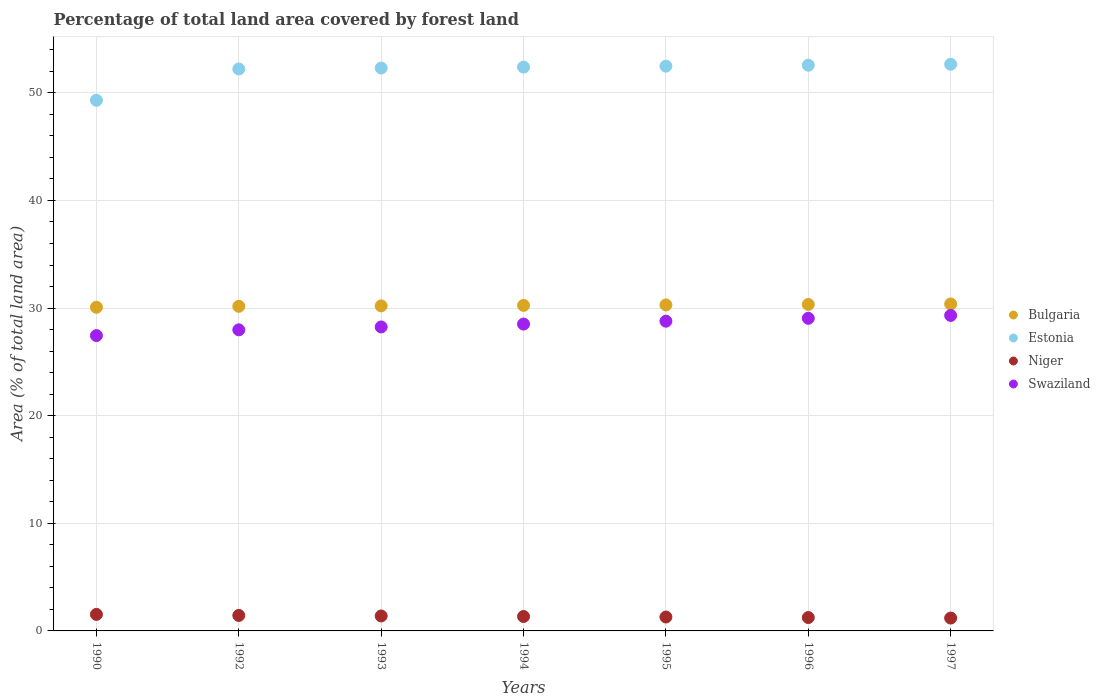What is the percentage of forest land in Niger in 1990?
Your answer should be very brief. 1.54. Across all years, what is the maximum percentage of forest land in Swaziland?
Make the answer very short. 29.31. Across all years, what is the minimum percentage of forest land in Estonia?
Your answer should be very brief. 49.3. In which year was the percentage of forest land in Niger maximum?
Ensure brevity in your answer.  1990. In which year was the percentage of forest land in Swaziland minimum?
Offer a terse response. 1990. What is the total percentage of forest land in Estonia in the graph?
Keep it short and to the point. 363.9. What is the difference between the percentage of forest land in Estonia in 1992 and that in 1996?
Your response must be concise. -0.35. What is the difference between the percentage of forest land in Estonia in 1990 and the percentage of forest land in Swaziland in 1996?
Give a very brief answer. 20.26. What is the average percentage of forest land in Estonia per year?
Offer a terse response. 51.99. In the year 1992, what is the difference between the percentage of forest land in Niger and percentage of forest land in Estonia?
Keep it short and to the point. -50.78. What is the ratio of the percentage of forest land in Niger in 1992 to that in 1993?
Ensure brevity in your answer.  1.04. Is the difference between the percentage of forest land in Niger in 1992 and 1997 greater than the difference between the percentage of forest land in Estonia in 1992 and 1997?
Make the answer very short. Yes. What is the difference between the highest and the second highest percentage of forest land in Estonia?
Give a very brief answer. 0.09. What is the difference between the highest and the lowest percentage of forest land in Estonia?
Make the answer very short. 3.35. In how many years, is the percentage of forest land in Estonia greater than the average percentage of forest land in Estonia taken over all years?
Provide a succinct answer. 6. Is it the case that in every year, the sum of the percentage of forest land in Estonia and percentage of forest land in Niger  is greater than the percentage of forest land in Bulgaria?
Your answer should be compact. Yes. Does the percentage of forest land in Estonia monotonically increase over the years?
Your answer should be compact. Yes. Is the percentage of forest land in Bulgaria strictly less than the percentage of forest land in Estonia over the years?
Ensure brevity in your answer.  Yes. What is the difference between two consecutive major ticks on the Y-axis?
Your response must be concise. 10. Where does the legend appear in the graph?
Provide a short and direct response. Center right. How many legend labels are there?
Your answer should be compact. 4. What is the title of the graph?
Keep it short and to the point. Percentage of total land area covered by forest land. Does "Antigua and Barbuda" appear as one of the legend labels in the graph?
Your answer should be compact. No. What is the label or title of the Y-axis?
Your response must be concise. Area (% of total land area). What is the Area (% of total land area) in Bulgaria in 1990?
Offer a very short reply. 30.07. What is the Area (% of total land area) in Estonia in 1990?
Ensure brevity in your answer.  49.3. What is the Area (% of total land area) of Niger in 1990?
Offer a terse response. 1.54. What is the Area (% of total land area) in Swaziland in 1990?
Ensure brevity in your answer.  27.44. What is the Area (% of total land area) of Bulgaria in 1992?
Your response must be concise. 30.16. What is the Area (% of total land area) in Estonia in 1992?
Provide a succinct answer. 52.22. What is the Area (% of total land area) in Niger in 1992?
Give a very brief answer. 1.44. What is the Area (% of total land area) of Swaziland in 1992?
Give a very brief answer. 27.98. What is the Area (% of total land area) of Bulgaria in 1993?
Provide a short and direct response. 30.2. What is the Area (% of total land area) of Estonia in 1993?
Ensure brevity in your answer.  52.3. What is the Area (% of total land area) in Niger in 1993?
Make the answer very short. 1.39. What is the Area (% of total land area) of Swaziland in 1993?
Your answer should be compact. 28.24. What is the Area (% of total land area) of Bulgaria in 1994?
Ensure brevity in your answer.  30.25. What is the Area (% of total land area) of Estonia in 1994?
Your answer should be very brief. 52.39. What is the Area (% of total land area) of Niger in 1994?
Give a very brief answer. 1.34. What is the Area (% of total land area) in Swaziland in 1994?
Offer a very short reply. 28.51. What is the Area (% of total land area) in Bulgaria in 1995?
Offer a very short reply. 30.29. What is the Area (% of total land area) in Estonia in 1995?
Your answer should be compact. 52.48. What is the Area (% of total land area) of Niger in 1995?
Your answer should be compact. 1.29. What is the Area (% of total land area) of Swaziland in 1995?
Offer a terse response. 28.78. What is the Area (% of total land area) in Bulgaria in 1996?
Your answer should be very brief. 30.33. What is the Area (% of total land area) of Estonia in 1996?
Your answer should be very brief. 52.56. What is the Area (% of total land area) in Niger in 1996?
Ensure brevity in your answer.  1.24. What is the Area (% of total land area) in Swaziland in 1996?
Offer a very short reply. 29.05. What is the Area (% of total land area) in Bulgaria in 1997?
Offer a very short reply. 30.38. What is the Area (% of total land area) in Estonia in 1997?
Offer a terse response. 52.65. What is the Area (% of total land area) of Niger in 1997?
Your response must be concise. 1.19. What is the Area (% of total land area) of Swaziland in 1997?
Provide a short and direct response. 29.31. Across all years, what is the maximum Area (% of total land area) in Bulgaria?
Provide a short and direct response. 30.38. Across all years, what is the maximum Area (% of total land area) of Estonia?
Your answer should be compact. 52.65. Across all years, what is the maximum Area (% of total land area) in Niger?
Your answer should be very brief. 1.54. Across all years, what is the maximum Area (% of total land area) in Swaziland?
Your answer should be compact. 29.31. Across all years, what is the minimum Area (% of total land area) in Bulgaria?
Keep it short and to the point. 30.07. Across all years, what is the minimum Area (% of total land area) in Estonia?
Your answer should be compact. 49.3. Across all years, what is the minimum Area (% of total land area) in Niger?
Your answer should be very brief. 1.19. Across all years, what is the minimum Area (% of total land area) in Swaziland?
Provide a succinct answer. 27.44. What is the total Area (% of total land area) in Bulgaria in the graph?
Offer a very short reply. 211.68. What is the total Area (% of total land area) in Estonia in the graph?
Your response must be concise. 363.9. What is the total Area (% of total land area) of Niger in the graph?
Keep it short and to the point. 9.43. What is the total Area (% of total land area) in Swaziland in the graph?
Give a very brief answer. 199.31. What is the difference between the Area (% of total land area) in Bulgaria in 1990 and that in 1992?
Keep it short and to the point. -0.09. What is the difference between the Area (% of total land area) in Estonia in 1990 and that in 1992?
Offer a very short reply. -2.91. What is the difference between the Area (% of total land area) of Niger in 1990 and that in 1992?
Provide a succinct answer. 0.1. What is the difference between the Area (% of total land area) in Swaziland in 1990 and that in 1992?
Provide a succinct answer. -0.53. What is the difference between the Area (% of total land area) of Bulgaria in 1990 and that in 1993?
Your answer should be compact. -0.13. What is the difference between the Area (% of total land area) of Estonia in 1990 and that in 1993?
Your answer should be compact. -3. What is the difference between the Area (% of total land area) of Niger in 1990 and that in 1993?
Provide a short and direct response. 0.15. What is the difference between the Area (% of total land area) of Swaziland in 1990 and that in 1993?
Give a very brief answer. -0.8. What is the difference between the Area (% of total land area) in Bulgaria in 1990 and that in 1994?
Ensure brevity in your answer.  -0.17. What is the difference between the Area (% of total land area) in Estonia in 1990 and that in 1994?
Keep it short and to the point. -3.09. What is the difference between the Area (% of total land area) of Niger in 1990 and that in 1994?
Make the answer very short. 0.19. What is the difference between the Area (% of total land area) in Swaziland in 1990 and that in 1994?
Ensure brevity in your answer.  -1.07. What is the difference between the Area (% of total land area) in Bulgaria in 1990 and that in 1995?
Provide a short and direct response. -0.22. What is the difference between the Area (% of total land area) of Estonia in 1990 and that in 1995?
Ensure brevity in your answer.  -3.17. What is the difference between the Area (% of total land area) in Niger in 1990 and that in 1995?
Offer a terse response. 0.24. What is the difference between the Area (% of total land area) in Swaziland in 1990 and that in 1995?
Your answer should be compact. -1.34. What is the difference between the Area (% of total land area) of Bulgaria in 1990 and that in 1996?
Give a very brief answer. -0.26. What is the difference between the Area (% of total land area) in Estonia in 1990 and that in 1996?
Keep it short and to the point. -3.26. What is the difference between the Area (% of total land area) in Niger in 1990 and that in 1996?
Your answer should be compact. 0.29. What is the difference between the Area (% of total land area) in Swaziland in 1990 and that in 1996?
Offer a very short reply. -1.6. What is the difference between the Area (% of total land area) in Bulgaria in 1990 and that in 1997?
Provide a short and direct response. -0.3. What is the difference between the Area (% of total land area) in Estonia in 1990 and that in 1997?
Your answer should be very brief. -3.35. What is the difference between the Area (% of total land area) in Niger in 1990 and that in 1997?
Offer a very short reply. 0.34. What is the difference between the Area (% of total land area) in Swaziland in 1990 and that in 1997?
Your answer should be compact. -1.87. What is the difference between the Area (% of total land area) in Bulgaria in 1992 and that in 1993?
Your answer should be very brief. -0.04. What is the difference between the Area (% of total land area) in Estonia in 1992 and that in 1993?
Keep it short and to the point. -0.09. What is the difference between the Area (% of total land area) in Niger in 1992 and that in 1993?
Make the answer very short. 0.05. What is the difference between the Area (% of total land area) in Swaziland in 1992 and that in 1993?
Offer a terse response. -0.27. What is the difference between the Area (% of total land area) of Bulgaria in 1992 and that in 1994?
Offer a very short reply. -0.09. What is the difference between the Area (% of total land area) of Estonia in 1992 and that in 1994?
Provide a succinct answer. -0.17. What is the difference between the Area (% of total land area) in Niger in 1992 and that in 1994?
Your answer should be compact. 0.1. What is the difference between the Area (% of total land area) in Swaziland in 1992 and that in 1994?
Make the answer very short. -0.53. What is the difference between the Area (% of total land area) of Bulgaria in 1992 and that in 1995?
Offer a very short reply. -0.13. What is the difference between the Area (% of total land area) in Estonia in 1992 and that in 1995?
Provide a short and direct response. -0.26. What is the difference between the Area (% of total land area) of Niger in 1992 and that in 1995?
Your response must be concise. 0.15. What is the difference between the Area (% of total land area) of Swaziland in 1992 and that in 1995?
Provide a succinct answer. -0.8. What is the difference between the Area (% of total land area) of Bulgaria in 1992 and that in 1996?
Your answer should be compact. -0.17. What is the difference between the Area (% of total land area) of Estonia in 1992 and that in 1996?
Give a very brief answer. -0.35. What is the difference between the Area (% of total land area) of Niger in 1992 and that in 1996?
Offer a terse response. 0.19. What is the difference between the Area (% of total land area) of Swaziland in 1992 and that in 1996?
Your answer should be compact. -1.07. What is the difference between the Area (% of total land area) in Bulgaria in 1992 and that in 1997?
Give a very brief answer. -0.22. What is the difference between the Area (% of total land area) in Estonia in 1992 and that in 1997?
Offer a terse response. -0.44. What is the difference between the Area (% of total land area) in Niger in 1992 and that in 1997?
Provide a short and direct response. 0.24. What is the difference between the Area (% of total land area) of Swaziland in 1992 and that in 1997?
Provide a short and direct response. -1.34. What is the difference between the Area (% of total land area) in Bulgaria in 1993 and that in 1994?
Provide a succinct answer. -0.04. What is the difference between the Area (% of total land area) of Estonia in 1993 and that in 1994?
Ensure brevity in your answer.  -0.09. What is the difference between the Area (% of total land area) in Niger in 1993 and that in 1994?
Give a very brief answer. 0.05. What is the difference between the Area (% of total land area) in Swaziland in 1993 and that in 1994?
Ensure brevity in your answer.  -0.27. What is the difference between the Area (% of total land area) of Bulgaria in 1993 and that in 1995?
Offer a terse response. -0.09. What is the difference between the Area (% of total land area) in Estonia in 1993 and that in 1995?
Give a very brief answer. -0.17. What is the difference between the Area (% of total land area) of Niger in 1993 and that in 1995?
Make the answer very short. 0.1. What is the difference between the Area (% of total land area) of Swaziland in 1993 and that in 1995?
Your answer should be very brief. -0.53. What is the difference between the Area (% of total land area) in Bulgaria in 1993 and that in 1996?
Offer a very short reply. -0.13. What is the difference between the Area (% of total land area) of Estonia in 1993 and that in 1996?
Keep it short and to the point. -0.26. What is the difference between the Area (% of total land area) of Niger in 1993 and that in 1996?
Make the answer very short. 0.15. What is the difference between the Area (% of total land area) of Swaziland in 1993 and that in 1996?
Make the answer very short. -0.8. What is the difference between the Area (% of total land area) in Bulgaria in 1993 and that in 1997?
Your answer should be very brief. -0.17. What is the difference between the Area (% of total land area) in Estonia in 1993 and that in 1997?
Provide a succinct answer. -0.35. What is the difference between the Area (% of total land area) in Niger in 1993 and that in 1997?
Your answer should be very brief. 0.19. What is the difference between the Area (% of total land area) in Swaziland in 1993 and that in 1997?
Keep it short and to the point. -1.07. What is the difference between the Area (% of total land area) in Bulgaria in 1994 and that in 1995?
Your answer should be compact. -0.04. What is the difference between the Area (% of total land area) in Estonia in 1994 and that in 1995?
Keep it short and to the point. -0.09. What is the difference between the Area (% of total land area) in Niger in 1994 and that in 1995?
Your answer should be compact. 0.05. What is the difference between the Area (% of total land area) in Swaziland in 1994 and that in 1995?
Make the answer very short. -0.27. What is the difference between the Area (% of total land area) in Bulgaria in 1994 and that in 1996?
Offer a terse response. -0.09. What is the difference between the Area (% of total land area) in Estonia in 1994 and that in 1996?
Offer a terse response. -0.17. What is the difference between the Area (% of total land area) of Niger in 1994 and that in 1996?
Your response must be concise. 0.1. What is the difference between the Area (% of total land area) of Swaziland in 1994 and that in 1996?
Your response must be concise. -0.53. What is the difference between the Area (% of total land area) of Bulgaria in 1994 and that in 1997?
Your answer should be very brief. -0.13. What is the difference between the Area (% of total land area) of Estonia in 1994 and that in 1997?
Your answer should be very brief. -0.26. What is the difference between the Area (% of total land area) of Niger in 1994 and that in 1997?
Make the answer very short. 0.15. What is the difference between the Area (% of total land area) of Swaziland in 1994 and that in 1997?
Provide a short and direct response. -0.8. What is the difference between the Area (% of total land area) of Bulgaria in 1995 and that in 1996?
Your response must be concise. -0.04. What is the difference between the Area (% of total land area) in Estonia in 1995 and that in 1996?
Offer a very short reply. -0.09. What is the difference between the Area (% of total land area) of Niger in 1995 and that in 1996?
Your answer should be very brief. 0.05. What is the difference between the Area (% of total land area) in Swaziland in 1995 and that in 1996?
Provide a succinct answer. -0.27. What is the difference between the Area (% of total land area) of Bulgaria in 1995 and that in 1997?
Keep it short and to the point. -0.09. What is the difference between the Area (% of total land area) in Estonia in 1995 and that in 1997?
Keep it short and to the point. -0.17. What is the difference between the Area (% of total land area) in Niger in 1995 and that in 1997?
Give a very brief answer. 0.1. What is the difference between the Area (% of total land area) of Swaziland in 1995 and that in 1997?
Your answer should be compact. -0.53. What is the difference between the Area (% of total land area) of Bulgaria in 1996 and that in 1997?
Keep it short and to the point. -0.04. What is the difference between the Area (% of total land area) in Estonia in 1996 and that in 1997?
Provide a succinct answer. -0.09. What is the difference between the Area (% of total land area) in Niger in 1996 and that in 1997?
Your answer should be very brief. 0.05. What is the difference between the Area (% of total land area) of Swaziland in 1996 and that in 1997?
Your response must be concise. -0.27. What is the difference between the Area (% of total land area) in Bulgaria in 1990 and the Area (% of total land area) in Estonia in 1992?
Your answer should be compact. -22.14. What is the difference between the Area (% of total land area) of Bulgaria in 1990 and the Area (% of total land area) of Niger in 1992?
Make the answer very short. 28.64. What is the difference between the Area (% of total land area) of Bulgaria in 1990 and the Area (% of total land area) of Swaziland in 1992?
Provide a short and direct response. 2.1. What is the difference between the Area (% of total land area) in Estonia in 1990 and the Area (% of total land area) in Niger in 1992?
Provide a short and direct response. 47.87. What is the difference between the Area (% of total land area) in Estonia in 1990 and the Area (% of total land area) in Swaziland in 1992?
Make the answer very short. 21.33. What is the difference between the Area (% of total land area) of Niger in 1990 and the Area (% of total land area) of Swaziland in 1992?
Give a very brief answer. -26.44. What is the difference between the Area (% of total land area) of Bulgaria in 1990 and the Area (% of total land area) of Estonia in 1993?
Your response must be concise. -22.23. What is the difference between the Area (% of total land area) of Bulgaria in 1990 and the Area (% of total land area) of Niger in 1993?
Your answer should be compact. 28.68. What is the difference between the Area (% of total land area) of Bulgaria in 1990 and the Area (% of total land area) of Swaziland in 1993?
Provide a short and direct response. 1.83. What is the difference between the Area (% of total land area) of Estonia in 1990 and the Area (% of total land area) of Niger in 1993?
Ensure brevity in your answer.  47.91. What is the difference between the Area (% of total land area) in Estonia in 1990 and the Area (% of total land area) in Swaziland in 1993?
Offer a terse response. 21.06. What is the difference between the Area (% of total land area) in Niger in 1990 and the Area (% of total land area) in Swaziland in 1993?
Your response must be concise. -26.71. What is the difference between the Area (% of total land area) in Bulgaria in 1990 and the Area (% of total land area) in Estonia in 1994?
Offer a very short reply. -22.32. What is the difference between the Area (% of total land area) of Bulgaria in 1990 and the Area (% of total land area) of Niger in 1994?
Provide a short and direct response. 28.73. What is the difference between the Area (% of total land area) of Bulgaria in 1990 and the Area (% of total land area) of Swaziland in 1994?
Offer a terse response. 1.56. What is the difference between the Area (% of total land area) of Estonia in 1990 and the Area (% of total land area) of Niger in 1994?
Give a very brief answer. 47.96. What is the difference between the Area (% of total land area) in Estonia in 1990 and the Area (% of total land area) in Swaziland in 1994?
Offer a terse response. 20.79. What is the difference between the Area (% of total land area) in Niger in 1990 and the Area (% of total land area) in Swaziland in 1994?
Offer a terse response. -26.98. What is the difference between the Area (% of total land area) in Bulgaria in 1990 and the Area (% of total land area) in Estonia in 1995?
Give a very brief answer. -22.4. What is the difference between the Area (% of total land area) of Bulgaria in 1990 and the Area (% of total land area) of Niger in 1995?
Give a very brief answer. 28.78. What is the difference between the Area (% of total land area) in Bulgaria in 1990 and the Area (% of total land area) in Swaziland in 1995?
Provide a short and direct response. 1.29. What is the difference between the Area (% of total land area) in Estonia in 1990 and the Area (% of total land area) in Niger in 1995?
Your answer should be very brief. 48.01. What is the difference between the Area (% of total land area) of Estonia in 1990 and the Area (% of total land area) of Swaziland in 1995?
Your answer should be very brief. 20.52. What is the difference between the Area (% of total land area) in Niger in 1990 and the Area (% of total land area) in Swaziland in 1995?
Provide a succinct answer. -27.24. What is the difference between the Area (% of total land area) of Bulgaria in 1990 and the Area (% of total land area) of Estonia in 1996?
Make the answer very short. -22.49. What is the difference between the Area (% of total land area) of Bulgaria in 1990 and the Area (% of total land area) of Niger in 1996?
Provide a short and direct response. 28.83. What is the difference between the Area (% of total land area) of Bulgaria in 1990 and the Area (% of total land area) of Swaziland in 1996?
Make the answer very short. 1.03. What is the difference between the Area (% of total land area) of Estonia in 1990 and the Area (% of total land area) of Niger in 1996?
Provide a succinct answer. 48.06. What is the difference between the Area (% of total land area) in Estonia in 1990 and the Area (% of total land area) in Swaziland in 1996?
Your answer should be compact. 20.26. What is the difference between the Area (% of total land area) in Niger in 1990 and the Area (% of total land area) in Swaziland in 1996?
Make the answer very short. -27.51. What is the difference between the Area (% of total land area) in Bulgaria in 1990 and the Area (% of total land area) in Estonia in 1997?
Provide a succinct answer. -22.58. What is the difference between the Area (% of total land area) in Bulgaria in 1990 and the Area (% of total land area) in Niger in 1997?
Your answer should be compact. 28.88. What is the difference between the Area (% of total land area) in Bulgaria in 1990 and the Area (% of total land area) in Swaziland in 1997?
Give a very brief answer. 0.76. What is the difference between the Area (% of total land area) of Estonia in 1990 and the Area (% of total land area) of Niger in 1997?
Your answer should be very brief. 48.11. What is the difference between the Area (% of total land area) of Estonia in 1990 and the Area (% of total land area) of Swaziland in 1997?
Keep it short and to the point. 19.99. What is the difference between the Area (% of total land area) of Niger in 1990 and the Area (% of total land area) of Swaziland in 1997?
Make the answer very short. -27.78. What is the difference between the Area (% of total land area) of Bulgaria in 1992 and the Area (% of total land area) of Estonia in 1993?
Give a very brief answer. -22.14. What is the difference between the Area (% of total land area) of Bulgaria in 1992 and the Area (% of total land area) of Niger in 1993?
Give a very brief answer. 28.77. What is the difference between the Area (% of total land area) of Bulgaria in 1992 and the Area (% of total land area) of Swaziland in 1993?
Your response must be concise. 1.92. What is the difference between the Area (% of total land area) in Estonia in 1992 and the Area (% of total land area) in Niger in 1993?
Make the answer very short. 50.83. What is the difference between the Area (% of total land area) of Estonia in 1992 and the Area (% of total land area) of Swaziland in 1993?
Give a very brief answer. 23.97. What is the difference between the Area (% of total land area) in Niger in 1992 and the Area (% of total land area) in Swaziland in 1993?
Provide a short and direct response. -26.81. What is the difference between the Area (% of total land area) of Bulgaria in 1992 and the Area (% of total land area) of Estonia in 1994?
Give a very brief answer. -22.23. What is the difference between the Area (% of total land area) in Bulgaria in 1992 and the Area (% of total land area) in Niger in 1994?
Provide a short and direct response. 28.82. What is the difference between the Area (% of total land area) in Bulgaria in 1992 and the Area (% of total land area) in Swaziland in 1994?
Your answer should be very brief. 1.65. What is the difference between the Area (% of total land area) of Estonia in 1992 and the Area (% of total land area) of Niger in 1994?
Provide a succinct answer. 50.87. What is the difference between the Area (% of total land area) of Estonia in 1992 and the Area (% of total land area) of Swaziland in 1994?
Provide a short and direct response. 23.7. What is the difference between the Area (% of total land area) in Niger in 1992 and the Area (% of total land area) in Swaziland in 1994?
Ensure brevity in your answer.  -27.07. What is the difference between the Area (% of total land area) in Bulgaria in 1992 and the Area (% of total land area) in Estonia in 1995?
Keep it short and to the point. -22.32. What is the difference between the Area (% of total land area) of Bulgaria in 1992 and the Area (% of total land area) of Niger in 1995?
Your answer should be compact. 28.87. What is the difference between the Area (% of total land area) in Bulgaria in 1992 and the Area (% of total land area) in Swaziland in 1995?
Your answer should be compact. 1.38. What is the difference between the Area (% of total land area) in Estonia in 1992 and the Area (% of total land area) in Niger in 1995?
Your response must be concise. 50.92. What is the difference between the Area (% of total land area) of Estonia in 1992 and the Area (% of total land area) of Swaziland in 1995?
Offer a terse response. 23.44. What is the difference between the Area (% of total land area) in Niger in 1992 and the Area (% of total land area) in Swaziland in 1995?
Ensure brevity in your answer.  -27.34. What is the difference between the Area (% of total land area) of Bulgaria in 1992 and the Area (% of total land area) of Estonia in 1996?
Your response must be concise. -22.4. What is the difference between the Area (% of total land area) in Bulgaria in 1992 and the Area (% of total land area) in Niger in 1996?
Provide a short and direct response. 28.92. What is the difference between the Area (% of total land area) of Bulgaria in 1992 and the Area (% of total land area) of Swaziland in 1996?
Make the answer very short. 1.11. What is the difference between the Area (% of total land area) in Estonia in 1992 and the Area (% of total land area) in Niger in 1996?
Your answer should be very brief. 50.97. What is the difference between the Area (% of total land area) of Estonia in 1992 and the Area (% of total land area) of Swaziland in 1996?
Your answer should be very brief. 23.17. What is the difference between the Area (% of total land area) in Niger in 1992 and the Area (% of total land area) in Swaziland in 1996?
Offer a very short reply. -27.61. What is the difference between the Area (% of total land area) in Bulgaria in 1992 and the Area (% of total land area) in Estonia in 1997?
Offer a terse response. -22.49. What is the difference between the Area (% of total land area) in Bulgaria in 1992 and the Area (% of total land area) in Niger in 1997?
Offer a very short reply. 28.97. What is the difference between the Area (% of total land area) in Bulgaria in 1992 and the Area (% of total land area) in Swaziland in 1997?
Ensure brevity in your answer.  0.85. What is the difference between the Area (% of total land area) in Estonia in 1992 and the Area (% of total land area) in Niger in 1997?
Provide a short and direct response. 51.02. What is the difference between the Area (% of total land area) of Estonia in 1992 and the Area (% of total land area) of Swaziland in 1997?
Give a very brief answer. 22.9. What is the difference between the Area (% of total land area) of Niger in 1992 and the Area (% of total land area) of Swaziland in 1997?
Your answer should be very brief. -27.88. What is the difference between the Area (% of total land area) in Bulgaria in 1993 and the Area (% of total land area) in Estonia in 1994?
Offer a very short reply. -22.19. What is the difference between the Area (% of total land area) of Bulgaria in 1993 and the Area (% of total land area) of Niger in 1994?
Keep it short and to the point. 28.86. What is the difference between the Area (% of total land area) in Bulgaria in 1993 and the Area (% of total land area) in Swaziland in 1994?
Give a very brief answer. 1.69. What is the difference between the Area (% of total land area) of Estonia in 1993 and the Area (% of total land area) of Niger in 1994?
Offer a terse response. 50.96. What is the difference between the Area (% of total land area) of Estonia in 1993 and the Area (% of total land area) of Swaziland in 1994?
Make the answer very short. 23.79. What is the difference between the Area (% of total land area) in Niger in 1993 and the Area (% of total land area) in Swaziland in 1994?
Keep it short and to the point. -27.12. What is the difference between the Area (% of total land area) in Bulgaria in 1993 and the Area (% of total land area) in Estonia in 1995?
Your response must be concise. -22.27. What is the difference between the Area (% of total land area) of Bulgaria in 1993 and the Area (% of total land area) of Niger in 1995?
Offer a very short reply. 28.91. What is the difference between the Area (% of total land area) in Bulgaria in 1993 and the Area (% of total land area) in Swaziland in 1995?
Keep it short and to the point. 1.42. What is the difference between the Area (% of total land area) in Estonia in 1993 and the Area (% of total land area) in Niger in 1995?
Your answer should be very brief. 51.01. What is the difference between the Area (% of total land area) in Estonia in 1993 and the Area (% of total land area) in Swaziland in 1995?
Offer a terse response. 23.52. What is the difference between the Area (% of total land area) of Niger in 1993 and the Area (% of total land area) of Swaziland in 1995?
Your answer should be very brief. -27.39. What is the difference between the Area (% of total land area) of Bulgaria in 1993 and the Area (% of total land area) of Estonia in 1996?
Make the answer very short. -22.36. What is the difference between the Area (% of total land area) in Bulgaria in 1993 and the Area (% of total land area) in Niger in 1996?
Make the answer very short. 28.96. What is the difference between the Area (% of total land area) in Bulgaria in 1993 and the Area (% of total land area) in Swaziland in 1996?
Offer a very short reply. 1.16. What is the difference between the Area (% of total land area) of Estonia in 1993 and the Area (% of total land area) of Niger in 1996?
Offer a very short reply. 51.06. What is the difference between the Area (% of total land area) of Estonia in 1993 and the Area (% of total land area) of Swaziland in 1996?
Your answer should be compact. 23.26. What is the difference between the Area (% of total land area) of Niger in 1993 and the Area (% of total land area) of Swaziland in 1996?
Offer a terse response. -27.66. What is the difference between the Area (% of total land area) of Bulgaria in 1993 and the Area (% of total land area) of Estonia in 1997?
Give a very brief answer. -22.45. What is the difference between the Area (% of total land area) in Bulgaria in 1993 and the Area (% of total land area) in Niger in 1997?
Keep it short and to the point. 29.01. What is the difference between the Area (% of total land area) of Bulgaria in 1993 and the Area (% of total land area) of Swaziland in 1997?
Make the answer very short. 0.89. What is the difference between the Area (% of total land area) in Estonia in 1993 and the Area (% of total land area) in Niger in 1997?
Your answer should be compact. 51.11. What is the difference between the Area (% of total land area) of Estonia in 1993 and the Area (% of total land area) of Swaziland in 1997?
Ensure brevity in your answer.  22.99. What is the difference between the Area (% of total land area) in Niger in 1993 and the Area (% of total land area) in Swaziland in 1997?
Your answer should be very brief. -27.92. What is the difference between the Area (% of total land area) in Bulgaria in 1994 and the Area (% of total land area) in Estonia in 1995?
Offer a very short reply. -22.23. What is the difference between the Area (% of total land area) of Bulgaria in 1994 and the Area (% of total land area) of Niger in 1995?
Provide a succinct answer. 28.95. What is the difference between the Area (% of total land area) of Bulgaria in 1994 and the Area (% of total land area) of Swaziland in 1995?
Your response must be concise. 1.47. What is the difference between the Area (% of total land area) of Estonia in 1994 and the Area (% of total land area) of Niger in 1995?
Give a very brief answer. 51.1. What is the difference between the Area (% of total land area) of Estonia in 1994 and the Area (% of total land area) of Swaziland in 1995?
Provide a succinct answer. 23.61. What is the difference between the Area (% of total land area) of Niger in 1994 and the Area (% of total land area) of Swaziland in 1995?
Provide a short and direct response. -27.44. What is the difference between the Area (% of total land area) in Bulgaria in 1994 and the Area (% of total land area) in Estonia in 1996?
Offer a very short reply. -22.32. What is the difference between the Area (% of total land area) in Bulgaria in 1994 and the Area (% of total land area) in Niger in 1996?
Offer a very short reply. 29. What is the difference between the Area (% of total land area) in Bulgaria in 1994 and the Area (% of total land area) in Swaziland in 1996?
Offer a very short reply. 1.2. What is the difference between the Area (% of total land area) in Estonia in 1994 and the Area (% of total land area) in Niger in 1996?
Make the answer very short. 51.15. What is the difference between the Area (% of total land area) in Estonia in 1994 and the Area (% of total land area) in Swaziland in 1996?
Keep it short and to the point. 23.34. What is the difference between the Area (% of total land area) in Niger in 1994 and the Area (% of total land area) in Swaziland in 1996?
Make the answer very short. -27.71. What is the difference between the Area (% of total land area) of Bulgaria in 1994 and the Area (% of total land area) of Estonia in 1997?
Offer a very short reply. -22.4. What is the difference between the Area (% of total land area) in Bulgaria in 1994 and the Area (% of total land area) in Niger in 1997?
Your answer should be very brief. 29.05. What is the difference between the Area (% of total land area) of Bulgaria in 1994 and the Area (% of total land area) of Swaziland in 1997?
Keep it short and to the point. 0.93. What is the difference between the Area (% of total land area) of Estonia in 1994 and the Area (% of total land area) of Niger in 1997?
Offer a terse response. 51.2. What is the difference between the Area (% of total land area) in Estonia in 1994 and the Area (% of total land area) in Swaziland in 1997?
Provide a succinct answer. 23.08. What is the difference between the Area (% of total land area) of Niger in 1994 and the Area (% of total land area) of Swaziland in 1997?
Make the answer very short. -27.97. What is the difference between the Area (% of total land area) in Bulgaria in 1995 and the Area (% of total land area) in Estonia in 1996?
Your answer should be compact. -22.27. What is the difference between the Area (% of total land area) of Bulgaria in 1995 and the Area (% of total land area) of Niger in 1996?
Ensure brevity in your answer.  29.05. What is the difference between the Area (% of total land area) in Bulgaria in 1995 and the Area (% of total land area) in Swaziland in 1996?
Ensure brevity in your answer.  1.24. What is the difference between the Area (% of total land area) of Estonia in 1995 and the Area (% of total land area) of Niger in 1996?
Provide a short and direct response. 51.23. What is the difference between the Area (% of total land area) of Estonia in 1995 and the Area (% of total land area) of Swaziland in 1996?
Give a very brief answer. 23.43. What is the difference between the Area (% of total land area) in Niger in 1995 and the Area (% of total land area) in Swaziland in 1996?
Offer a terse response. -27.75. What is the difference between the Area (% of total land area) of Bulgaria in 1995 and the Area (% of total land area) of Estonia in 1997?
Offer a terse response. -22.36. What is the difference between the Area (% of total land area) in Bulgaria in 1995 and the Area (% of total land area) in Niger in 1997?
Your answer should be compact. 29.1. What is the difference between the Area (% of total land area) of Bulgaria in 1995 and the Area (% of total land area) of Swaziland in 1997?
Ensure brevity in your answer.  0.98. What is the difference between the Area (% of total land area) of Estonia in 1995 and the Area (% of total land area) of Niger in 1997?
Offer a very short reply. 51.28. What is the difference between the Area (% of total land area) of Estonia in 1995 and the Area (% of total land area) of Swaziland in 1997?
Your answer should be compact. 23.16. What is the difference between the Area (% of total land area) in Niger in 1995 and the Area (% of total land area) in Swaziland in 1997?
Provide a succinct answer. -28.02. What is the difference between the Area (% of total land area) of Bulgaria in 1996 and the Area (% of total land area) of Estonia in 1997?
Offer a terse response. -22.32. What is the difference between the Area (% of total land area) of Bulgaria in 1996 and the Area (% of total land area) of Niger in 1997?
Provide a short and direct response. 29.14. What is the difference between the Area (% of total land area) of Bulgaria in 1996 and the Area (% of total land area) of Swaziland in 1997?
Make the answer very short. 1.02. What is the difference between the Area (% of total land area) in Estonia in 1996 and the Area (% of total land area) in Niger in 1997?
Make the answer very short. 51.37. What is the difference between the Area (% of total land area) of Estonia in 1996 and the Area (% of total land area) of Swaziland in 1997?
Give a very brief answer. 23.25. What is the difference between the Area (% of total land area) of Niger in 1996 and the Area (% of total land area) of Swaziland in 1997?
Provide a short and direct response. -28.07. What is the average Area (% of total land area) of Bulgaria per year?
Make the answer very short. 30.24. What is the average Area (% of total land area) of Estonia per year?
Keep it short and to the point. 51.99. What is the average Area (% of total land area) of Niger per year?
Ensure brevity in your answer.  1.35. What is the average Area (% of total land area) in Swaziland per year?
Offer a terse response. 28.47. In the year 1990, what is the difference between the Area (% of total land area) in Bulgaria and Area (% of total land area) in Estonia?
Your response must be concise. -19.23. In the year 1990, what is the difference between the Area (% of total land area) of Bulgaria and Area (% of total land area) of Niger?
Give a very brief answer. 28.54. In the year 1990, what is the difference between the Area (% of total land area) in Bulgaria and Area (% of total land area) in Swaziland?
Your answer should be very brief. 2.63. In the year 1990, what is the difference between the Area (% of total land area) in Estonia and Area (% of total land area) in Niger?
Make the answer very short. 47.77. In the year 1990, what is the difference between the Area (% of total land area) in Estonia and Area (% of total land area) in Swaziland?
Ensure brevity in your answer.  21.86. In the year 1990, what is the difference between the Area (% of total land area) in Niger and Area (% of total land area) in Swaziland?
Your answer should be very brief. -25.91. In the year 1992, what is the difference between the Area (% of total land area) in Bulgaria and Area (% of total land area) in Estonia?
Your answer should be very brief. -22.06. In the year 1992, what is the difference between the Area (% of total land area) of Bulgaria and Area (% of total land area) of Niger?
Provide a short and direct response. 28.72. In the year 1992, what is the difference between the Area (% of total land area) in Bulgaria and Area (% of total land area) in Swaziland?
Offer a terse response. 2.18. In the year 1992, what is the difference between the Area (% of total land area) in Estonia and Area (% of total land area) in Niger?
Offer a terse response. 50.78. In the year 1992, what is the difference between the Area (% of total land area) of Estonia and Area (% of total land area) of Swaziland?
Give a very brief answer. 24.24. In the year 1992, what is the difference between the Area (% of total land area) of Niger and Area (% of total land area) of Swaziland?
Keep it short and to the point. -26.54. In the year 1993, what is the difference between the Area (% of total land area) in Bulgaria and Area (% of total land area) in Estonia?
Make the answer very short. -22.1. In the year 1993, what is the difference between the Area (% of total land area) in Bulgaria and Area (% of total land area) in Niger?
Your response must be concise. 28.81. In the year 1993, what is the difference between the Area (% of total land area) of Bulgaria and Area (% of total land area) of Swaziland?
Ensure brevity in your answer.  1.96. In the year 1993, what is the difference between the Area (% of total land area) of Estonia and Area (% of total land area) of Niger?
Your answer should be very brief. 50.91. In the year 1993, what is the difference between the Area (% of total land area) in Estonia and Area (% of total land area) in Swaziland?
Offer a terse response. 24.06. In the year 1993, what is the difference between the Area (% of total land area) of Niger and Area (% of total land area) of Swaziland?
Make the answer very short. -26.85. In the year 1994, what is the difference between the Area (% of total land area) in Bulgaria and Area (% of total land area) in Estonia?
Offer a terse response. -22.14. In the year 1994, what is the difference between the Area (% of total land area) of Bulgaria and Area (% of total land area) of Niger?
Make the answer very short. 28.91. In the year 1994, what is the difference between the Area (% of total land area) in Bulgaria and Area (% of total land area) in Swaziland?
Keep it short and to the point. 1.74. In the year 1994, what is the difference between the Area (% of total land area) in Estonia and Area (% of total land area) in Niger?
Provide a succinct answer. 51.05. In the year 1994, what is the difference between the Area (% of total land area) of Estonia and Area (% of total land area) of Swaziland?
Your response must be concise. 23.88. In the year 1994, what is the difference between the Area (% of total land area) of Niger and Area (% of total land area) of Swaziland?
Your answer should be very brief. -27.17. In the year 1995, what is the difference between the Area (% of total land area) of Bulgaria and Area (% of total land area) of Estonia?
Ensure brevity in your answer.  -22.19. In the year 1995, what is the difference between the Area (% of total land area) in Bulgaria and Area (% of total land area) in Niger?
Your answer should be very brief. 29. In the year 1995, what is the difference between the Area (% of total land area) in Bulgaria and Area (% of total land area) in Swaziland?
Your answer should be very brief. 1.51. In the year 1995, what is the difference between the Area (% of total land area) of Estonia and Area (% of total land area) of Niger?
Give a very brief answer. 51.19. In the year 1995, what is the difference between the Area (% of total land area) of Estonia and Area (% of total land area) of Swaziland?
Offer a terse response. 23.7. In the year 1995, what is the difference between the Area (% of total land area) of Niger and Area (% of total land area) of Swaziland?
Give a very brief answer. -27.49. In the year 1996, what is the difference between the Area (% of total land area) of Bulgaria and Area (% of total land area) of Estonia?
Offer a terse response. -22.23. In the year 1996, what is the difference between the Area (% of total land area) of Bulgaria and Area (% of total land area) of Niger?
Offer a terse response. 29.09. In the year 1996, what is the difference between the Area (% of total land area) in Bulgaria and Area (% of total land area) in Swaziland?
Provide a succinct answer. 1.29. In the year 1996, what is the difference between the Area (% of total land area) in Estonia and Area (% of total land area) in Niger?
Your answer should be very brief. 51.32. In the year 1996, what is the difference between the Area (% of total land area) of Estonia and Area (% of total land area) of Swaziland?
Offer a terse response. 23.52. In the year 1996, what is the difference between the Area (% of total land area) of Niger and Area (% of total land area) of Swaziland?
Provide a succinct answer. -27.8. In the year 1997, what is the difference between the Area (% of total land area) of Bulgaria and Area (% of total land area) of Estonia?
Ensure brevity in your answer.  -22.27. In the year 1997, what is the difference between the Area (% of total land area) of Bulgaria and Area (% of total land area) of Niger?
Offer a very short reply. 29.18. In the year 1997, what is the difference between the Area (% of total land area) in Bulgaria and Area (% of total land area) in Swaziland?
Your response must be concise. 1.06. In the year 1997, what is the difference between the Area (% of total land area) of Estonia and Area (% of total land area) of Niger?
Your response must be concise. 51.46. In the year 1997, what is the difference between the Area (% of total land area) in Estonia and Area (% of total land area) in Swaziland?
Offer a very short reply. 23.34. In the year 1997, what is the difference between the Area (% of total land area) of Niger and Area (% of total land area) of Swaziland?
Offer a terse response. -28.12. What is the ratio of the Area (% of total land area) of Estonia in 1990 to that in 1992?
Your answer should be very brief. 0.94. What is the ratio of the Area (% of total land area) in Niger in 1990 to that in 1992?
Your answer should be compact. 1.07. What is the ratio of the Area (% of total land area) of Swaziland in 1990 to that in 1992?
Ensure brevity in your answer.  0.98. What is the ratio of the Area (% of total land area) of Bulgaria in 1990 to that in 1993?
Offer a very short reply. 1. What is the ratio of the Area (% of total land area) in Estonia in 1990 to that in 1993?
Offer a very short reply. 0.94. What is the ratio of the Area (% of total land area) in Niger in 1990 to that in 1993?
Your answer should be compact. 1.11. What is the ratio of the Area (% of total land area) in Swaziland in 1990 to that in 1993?
Make the answer very short. 0.97. What is the ratio of the Area (% of total land area) of Bulgaria in 1990 to that in 1994?
Make the answer very short. 0.99. What is the ratio of the Area (% of total land area) in Estonia in 1990 to that in 1994?
Make the answer very short. 0.94. What is the ratio of the Area (% of total land area) in Niger in 1990 to that in 1994?
Ensure brevity in your answer.  1.15. What is the ratio of the Area (% of total land area) in Swaziland in 1990 to that in 1994?
Provide a short and direct response. 0.96. What is the ratio of the Area (% of total land area) of Bulgaria in 1990 to that in 1995?
Keep it short and to the point. 0.99. What is the ratio of the Area (% of total land area) of Estonia in 1990 to that in 1995?
Make the answer very short. 0.94. What is the ratio of the Area (% of total land area) in Niger in 1990 to that in 1995?
Offer a terse response. 1.19. What is the ratio of the Area (% of total land area) of Swaziland in 1990 to that in 1995?
Your answer should be very brief. 0.95. What is the ratio of the Area (% of total land area) in Estonia in 1990 to that in 1996?
Make the answer very short. 0.94. What is the ratio of the Area (% of total land area) of Niger in 1990 to that in 1996?
Your answer should be compact. 1.24. What is the ratio of the Area (% of total land area) in Swaziland in 1990 to that in 1996?
Ensure brevity in your answer.  0.94. What is the ratio of the Area (% of total land area) in Estonia in 1990 to that in 1997?
Offer a terse response. 0.94. What is the ratio of the Area (% of total land area) of Niger in 1990 to that in 1997?
Offer a terse response. 1.29. What is the ratio of the Area (% of total land area) of Swaziland in 1990 to that in 1997?
Ensure brevity in your answer.  0.94. What is the ratio of the Area (% of total land area) of Bulgaria in 1992 to that in 1993?
Make the answer very short. 1. What is the ratio of the Area (% of total land area) of Estonia in 1992 to that in 1993?
Keep it short and to the point. 1. What is the ratio of the Area (% of total land area) of Niger in 1992 to that in 1993?
Ensure brevity in your answer.  1.04. What is the ratio of the Area (% of total land area) in Swaziland in 1992 to that in 1993?
Give a very brief answer. 0.99. What is the ratio of the Area (% of total land area) in Bulgaria in 1992 to that in 1994?
Keep it short and to the point. 1. What is the ratio of the Area (% of total land area) of Niger in 1992 to that in 1994?
Your answer should be very brief. 1.07. What is the ratio of the Area (% of total land area) of Swaziland in 1992 to that in 1994?
Give a very brief answer. 0.98. What is the ratio of the Area (% of total land area) in Niger in 1992 to that in 1995?
Ensure brevity in your answer.  1.11. What is the ratio of the Area (% of total land area) of Swaziland in 1992 to that in 1995?
Offer a terse response. 0.97. What is the ratio of the Area (% of total land area) of Estonia in 1992 to that in 1996?
Your response must be concise. 0.99. What is the ratio of the Area (% of total land area) of Niger in 1992 to that in 1996?
Your response must be concise. 1.16. What is the ratio of the Area (% of total land area) in Swaziland in 1992 to that in 1996?
Provide a succinct answer. 0.96. What is the ratio of the Area (% of total land area) of Bulgaria in 1992 to that in 1997?
Your response must be concise. 0.99. What is the ratio of the Area (% of total land area) of Niger in 1992 to that in 1997?
Give a very brief answer. 1.2. What is the ratio of the Area (% of total land area) of Swaziland in 1992 to that in 1997?
Your answer should be compact. 0.95. What is the ratio of the Area (% of total land area) in Estonia in 1993 to that in 1994?
Your response must be concise. 1. What is the ratio of the Area (% of total land area) in Niger in 1993 to that in 1994?
Provide a succinct answer. 1.04. What is the ratio of the Area (% of total land area) of Swaziland in 1993 to that in 1994?
Provide a short and direct response. 0.99. What is the ratio of the Area (% of total land area) in Bulgaria in 1993 to that in 1995?
Make the answer very short. 1. What is the ratio of the Area (% of total land area) in Niger in 1993 to that in 1995?
Your answer should be compact. 1.08. What is the ratio of the Area (% of total land area) of Swaziland in 1993 to that in 1995?
Give a very brief answer. 0.98. What is the ratio of the Area (% of total land area) of Bulgaria in 1993 to that in 1996?
Make the answer very short. 1. What is the ratio of the Area (% of total land area) of Niger in 1993 to that in 1996?
Your answer should be very brief. 1.12. What is the ratio of the Area (% of total land area) in Swaziland in 1993 to that in 1996?
Your response must be concise. 0.97. What is the ratio of the Area (% of total land area) of Estonia in 1993 to that in 1997?
Offer a very short reply. 0.99. What is the ratio of the Area (% of total land area) of Niger in 1993 to that in 1997?
Your response must be concise. 1.16. What is the ratio of the Area (% of total land area) in Swaziland in 1993 to that in 1997?
Your response must be concise. 0.96. What is the ratio of the Area (% of total land area) in Estonia in 1994 to that in 1995?
Offer a very short reply. 1. What is the ratio of the Area (% of total land area) in Niger in 1994 to that in 1995?
Ensure brevity in your answer.  1.04. What is the ratio of the Area (% of total land area) of Swaziland in 1994 to that in 1995?
Keep it short and to the point. 0.99. What is the ratio of the Area (% of total land area) of Estonia in 1994 to that in 1996?
Provide a succinct answer. 1. What is the ratio of the Area (% of total land area) in Niger in 1994 to that in 1996?
Your answer should be compact. 1.08. What is the ratio of the Area (% of total land area) of Swaziland in 1994 to that in 1996?
Your answer should be very brief. 0.98. What is the ratio of the Area (% of total land area) of Bulgaria in 1994 to that in 1997?
Provide a short and direct response. 1. What is the ratio of the Area (% of total land area) of Estonia in 1994 to that in 1997?
Provide a short and direct response. 0.99. What is the ratio of the Area (% of total land area) in Niger in 1994 to that in 1997?
Your answer should be very brief. 1.12. What is the ratio of the Area (% of total land area) in Swaziland in 1994 to that in 1997?
Make the answer very short. 0.97. What is the ratio of the Area (% of total land area) in Niger in 1995 to that in 1996?
Provide a succinct answer. 1.04. What is the ratio of the Area (% of total land area) of Niger in 1995 to that in 1997?
Provide a succinct answer. 1.08. What is the ratio of the Area (% of total land area) of Swaziland in 1995 to that in 1997?
Your answer should be very brief. 0.98. What is the ratio of the Area (% of total land area) in Bulgaria in 1996 to that in 1997?
Your answer should be compact. 1. What is the ratio of the Area (% of total land area) in Estonia in 1996 to that in 1997?
Provide a succinct answer. 1. What is the ratio of the Area (% of total land area) of Niger in 1996 to that in 1997?
Your response must be concise. 1.04. What is the ratio of the Area (% of total land area) of Swaziland in 1996 to that in 1997?
Provide a succinct answer. 0.99. What is the difference between the highest and the second highest Area (% of total land area) in Bulgaria?
Provide a succinct answer. 0.04. What is the difference between the highest and the second highest Area (% of total land area) in Estonia?
Provide a short and direct response. 0.09. What is the difference between the highest and the second highest Area (% of total land area) in Niger?
Your answer should be very brief. 0.1. What is the difference between the highest and the second highest Area (% of total land area) in Swaziland?
Offer a very short reply. 0.27. What is the difference between the highest and the lowest Area (% of total land area) in Bulgaria?
Provide a succinct answer. 0.3. What is the difference between the highest and the lowest Area (% of total land area) of Estonia?
Offer a very short reply. 3.35. What is the difference between the highest and the lowest Area (% of total land area) of Niger?
Offer a terse response. 0.34. What is the difference between the highest and the lowest Area (% of total land area) of Swaziland?
Keep it short and to the point. 1.87. 